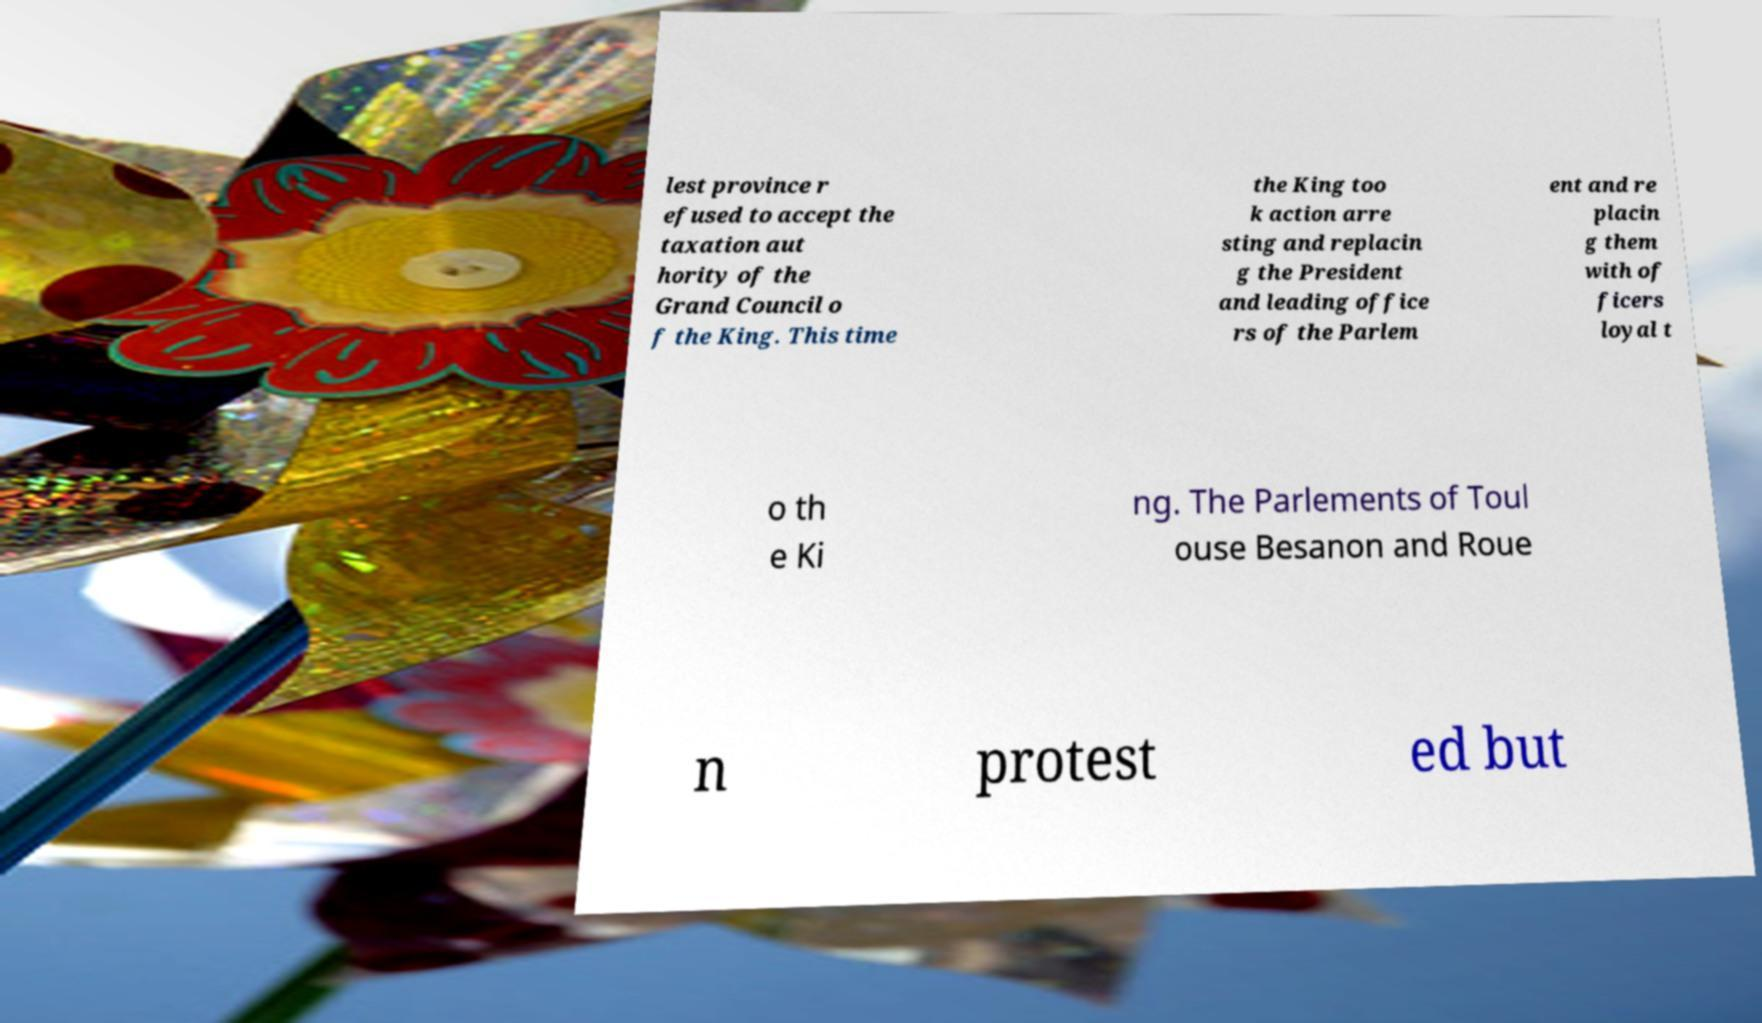I need the written content from this picture converted into text. Can you do that? lest province r efused to accept the taxation aut hority of the Grand Council o f the King. This time the King too k action arre sting and replacin g the President and leading office rs of the Parlem ent and re placin g them with of ficers loyal t o th e Ki ng. The Parlements of Toul ouse Besanon and Roue n protest ed but 